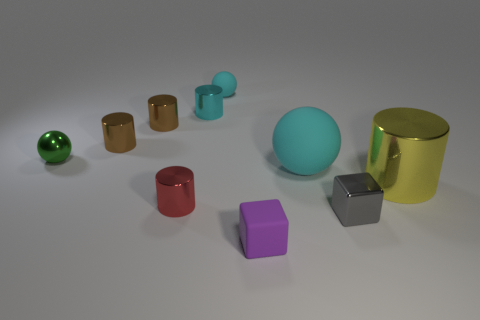Subtract all red metal cylinders. How many cylinders are left? 4 Subtract all purple cubes. How many cubes are left? 1 Subtract 4 cylinders. How many cylinders are left? 1 Add 5 large metallic things. How many large metallic things exist? 6 Subtract 1 green spheres. How many objects are left? 9 Subtract all blocks. How many objects are left? 8 Subtract all brown balls. Subtract all brown cylinders. How many balls are left? 3 Subtract all yellow spheres. How many brown cylinders are left? 2 Subtract all tiny gray blocks. Subtract all large purple rubber cubes. How many objects are left? 9 Add 4 small purple rubber blocks. How many small purple rubber blocks are left? 5 